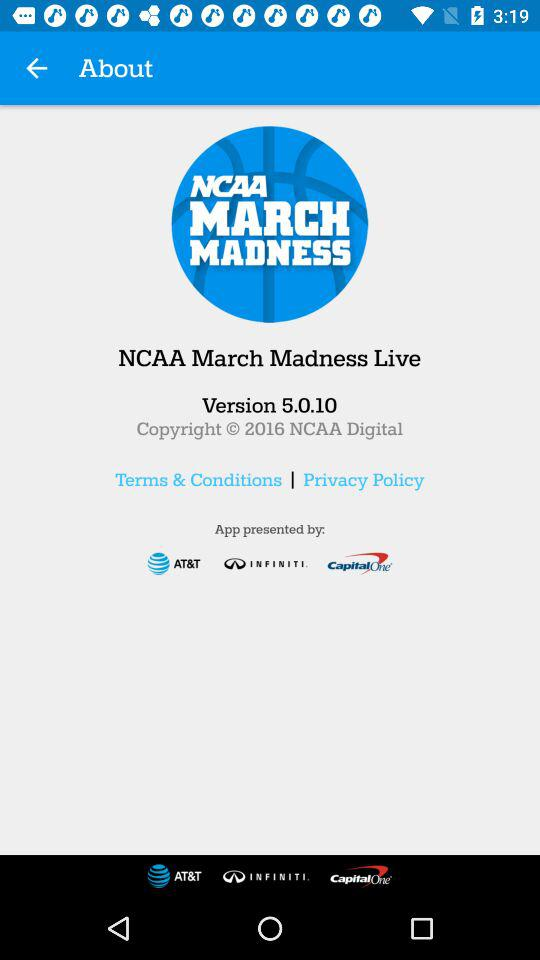What is the version of the application? The version is 5.0.10. 